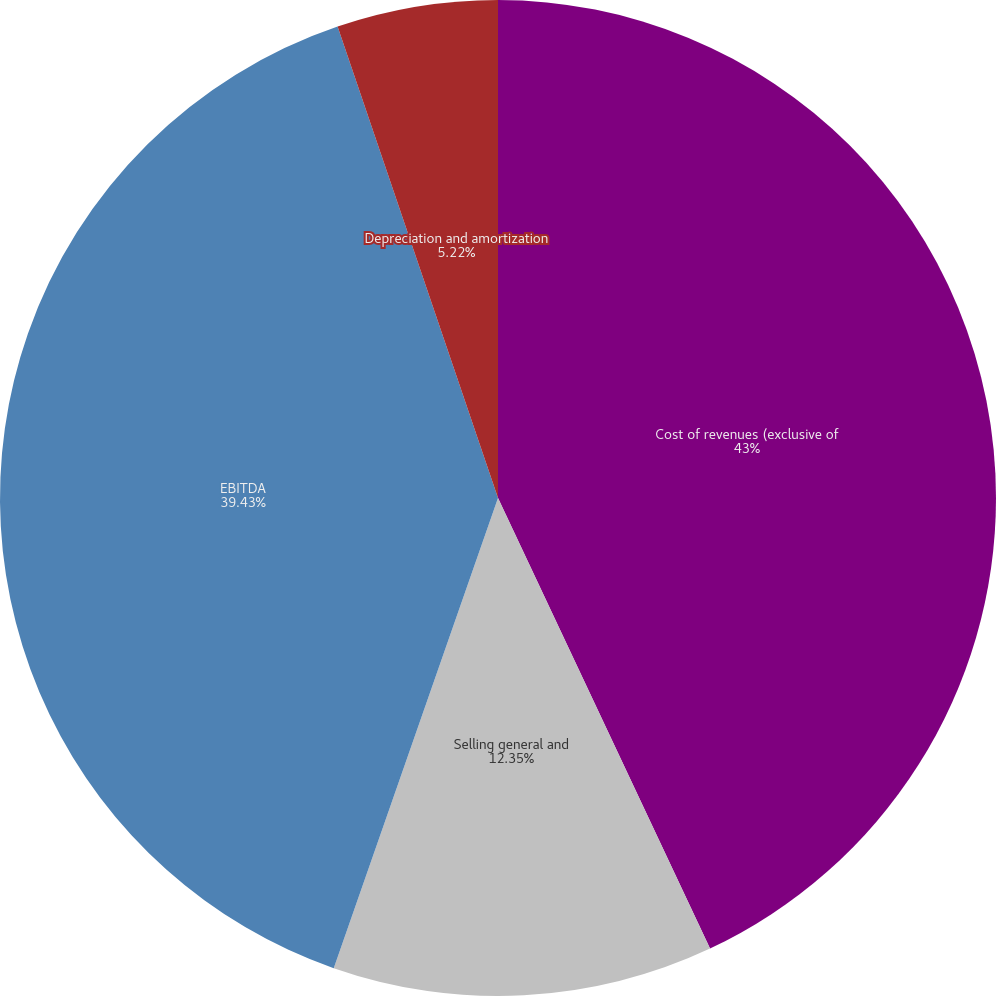<chart> <loc_0><loc_0><loc_500><loc_500><pie_chart><fcel>Cost of revenues (exclusive of<fcel>Selling general and<fcel>EBITDA<fcel>Depreciation and amortization<nl><fcel>43.0%<fcel>12.35%<fcel>39.43%<fcel>5.22%<nl></chart> 